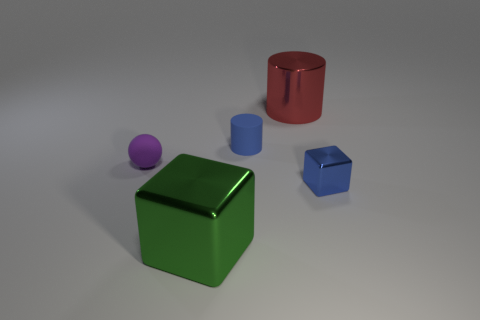Add 3 small purple things. How many objects exist? 8 Subtract all cylinders. How many objects are left? 3 Add 2 tiny blue blocks. How many tiny blue blocks exist? 3 Subtract 0 gray balls. How many objects are left? 5 Subtract all big shiny balls. Subtract all small balls. How many objects are left? 4 Add 1 blue cylinders. How many blue cylinders are left? 2 